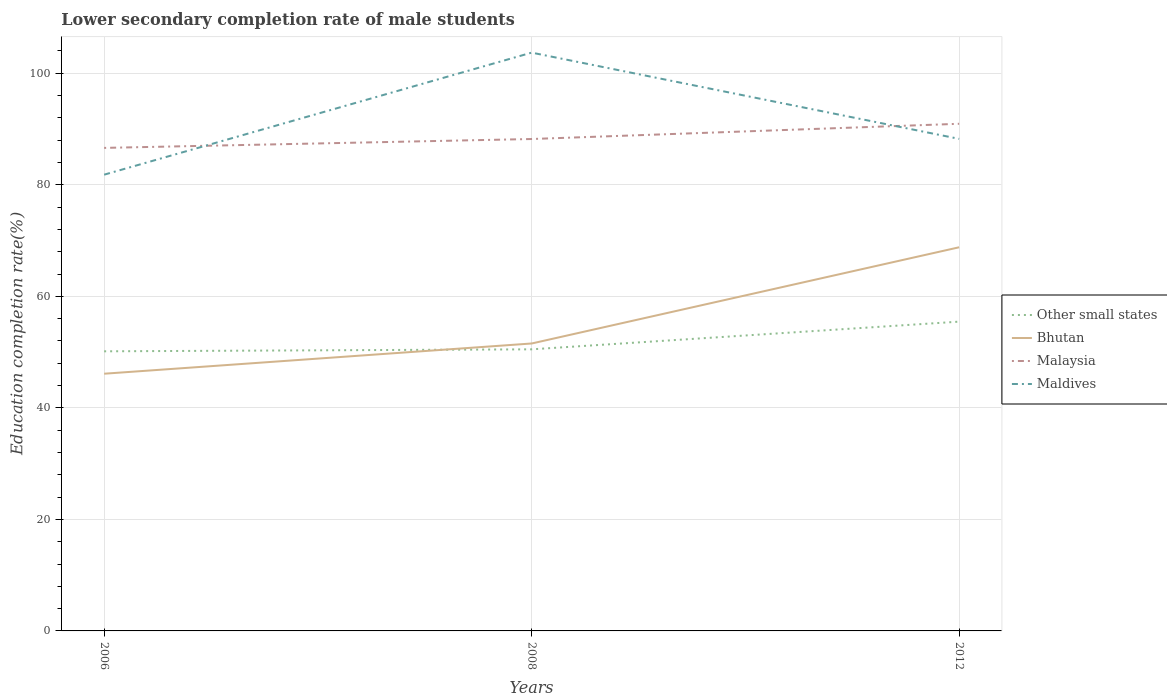How many different coloured lines are there?
Provide a short and direct response. 4. Is the number of lines equal to the number of legend labels?
Ensure brevity in your answer.  Yes. Across all years, what is the maximum lower secondary completion rate of male students in Bhutan?
Offer a very short reply. 46.12. In which year was the lower secondary completion rate of male students in Maldives maximum?
Make the answer very short. 2006. What is the total lower secondary completion rate of male students in Bhutan in the graph?
Provide a succinct answer. -22.68. What is the difference between the highest and the second highest lower secondary completion rate of male students in Bhutan?
Give a very brief answer. 22.68. Does the graph contain any zero values?
Make the answer very short. No. How many legend labels are there?
Provide a short and direct response. 4. How are the legend labels stacked?
Make the answer very short. Vertical. What is the title of the graph?
Provide a short and direct response. Lower secondary completion rate of male students. What is the label or title of the X-axis?
Provide a succinct answer. Years. What is the label or title of the Y-axis?
Ensure brevity in your answer.  Education completion rate(%). What is the Education completion rate(%) in Other small states in 2006?
Ensure brevity in your answer.  50.14. What is the Education completion rate(%) of Bhutan in 2006?
Offer a very short reply. 46.12. What is the Education completion rate(%) of Malaysia in 2006?
Offer a very short reply. 86.62. What is the Education completion rate(%) in Maldives in 2006?
Offer a terse response. 81.82. What is the Education completion rate(%) of Other small states in 2008?
Offer a terse response. 50.5. What is the Education completion rate(%) in Bhutan in 2008?
Keep it short and to the point. 51.54. What is the Education completion rate(%) in Malaysia in 2008?
Make the answer very short. 88.21. What is the Education completion rate(%) of Maldives in 2008?
Provide a succinct answer. 103.7. What is the Education completion rate(%) in Other small states in 2012?
Offer a terse response. 55.46. What is the Education completion rate(%) of Bhutan in 2012?
Provide a succinct answer. 68.8. What is the Education completion rate(%) of Malaysia in 2012?
Give a very brief answer. 90.94. What is the Education completion rate(%) in Maldives in 2012?
Make the answer very short. 88.24. Across all years, what is the maximum Education completion rate(%) of Other small states?
Provide a succinct answer. 55.46. Across all years, what is the maximum Education completion rate(%) in Bhutan?
Offer a terse response. 68.8. Across all years, what is the maximum Education completion rate(%) in Malaysia?
Offer a terse response. 90.94. Across all years, what is the maximum Education completion rate(%) of Maldives?
Keep it short and to the point. 103.7. Across all years, what is the minimum Education completion rate(%) of Other small states?
Offer a very short reply. 50.14. Across all years, what is the minimum Education completion rate(%) in Bhutan?
Your answer should be compact. 46.12. Across all years, what is the minimum Education completion rate(%) in Malaysia?
Ensure brevity in your answer.  86.62. Across all years, what is the minimum Education completion rate(%) in Maldives?
Offer a terse response. 81.82. What is the total Education completion rate(%) in Other small states in the graph?
Keep it short and to the point. 156.1. What is the total Education completion rate(%) of Bhutan in the graph?
Make the answer very short. 166.46. What is the total Education completion rate(%) in Malaysia in the graph?
Provide a succinct answer. 265.77. What is the total Education completion rate(%) in Maldives in the graph?
Offer a very short reply. 273.75. What is the difference between the Education completion rate(%) of Other small states in 2006 and that in 2008?
Provide a short and direct response. -0.36. What is the difference between the Education completion rate(%) in Bhutan in 2006 and that in 2008?
Give a very brief answer. -5.42. What is the difference between the Education completion rate(%) in Malaysia in 2006 and that in 2008?
Ensure brevity in your answer.  -1.59. What is the difference between the Education completion rate(%) in Maldives in 2006 and that in 2008?
Provide a short and direct response. -21.89. What is the difference between the Education completion rate(%) in Other small states in 2006 and that in 2012?
Give a very brief answer. -5.32. What is the difference between the Education completion rate(%) of Bhutan in 2006 and that in 2012?
Your response must be concise. -22.68. What is the difference between the Education completion rate(%) in Malaysia in 2006 and that in 2012?
Keep it short and to the point. -4.32. What is the difference between the Education completion rate(%) of Maldives in 2006 and that in 2012?
Make the answer very short. -6.42. What is the difference between the Education completion rate(%) in Other small states in 2008 and that in 2012?
Your answer should be compact. -4.97. What is the difference between the Education completion rate(%) in Bhutan in 2008 and that in 2012?
Give a very brief answer. -17.25. What is the difference between the Education completion rate(%) in Malaysia in 2008 and that in 2012?
Your answer should be compact. -2.73. What is the difference between the Education completion rate(%) in Maldives in 2008 and that in 2012?
Provide a succinct answer. 15.46. What is the difference between the Education completion rate(%) of Other small states in 2006 and the Education completion rate(%) of Bhutan in 2008?
Your answer should be compact. -1.4. What is the difference between the Education completion rate(%) of Other small states in 2006 and the Education completion rate(%) of Malaysia in 2008?
Provide a succinct answer. -38.07. What is the difference between the Education completion rate(%) of Other small states in 2006 and the Education completion rate(%) of Maldives in 2008?
Your answer should be compact. -53.56. What is the difference between the Education completion rate(%) of Bhutan in 2006 and the Education completion rate(%) of Malaysia in 2008?
Your answer should be very brief. -42.09. What is the difference between the Education completion rate(%) of Bhutan in 2006 and the Education completion rate(%) of Maldives in 2008?
Your answer should be very brief. -57.58. What is the difference between the Education completion rate(%) of Malaysia in 2006 and the Education completion rate(%) of Maldives in 2008?
Provide a short and direct response. -17.08. What is the difference between the Education completion rate(%) in Other small states in 2006 and the Education completion rate(%) in Bhutan in 2012?
Offer a very short reply. -18.66. What is the difference between the Education completion rate(%) of Other small states in 2006 and the Education completion rate(%) of Malaysia in 2012?
Provide a short and direct response. -40.8. What is the difference between the Education completion rate(%) of Other small states in 2006 and the Education completion rate(%) of Maldives in 2012?
Offer a terse response. -38.1. What is the difference between the Education completion rate(%) in Bhutan in 2006 and the Education completion rate(%) in Malaysia in 2012?
Your answer should be very brief. -44.82. What is the difference between the Education completion rate(%) in Bhutan in 2006 and the Education completion rate(%) in Maldives in 2012?
Ensure brevity in your answer.  -42.11. What is the difference between the Education completion rate(%) in Malaysia in 2006 and the Education completion rate(%) in Maldives in 2012?
Your response must be concise. -1.62. What is the difference between the Education completion rate(%) in Other small states in 2008 and the Education completion rate(%) in Bhutan in 2012?
Give a very brief answer. -18.3. What is the difference between the Education completion rate(%) of Other small states in 2008 and the Education completion rate(%) of Malaysia in 2012?
Provide a short and direct response. -40.45. What is the difference between the Education completion rate(%) in Other small states in 2008 and the Education completion rate(%) in Maldives in 2012?
Offer a terse response. -37.74. What is the difference between the Education completion rate(%) of Bhutan in 2008 and the Education completion rate(%) of Malaysia in 2012?
Your answer should be very brief. -39.4. What is the difference between the Education completion rate(%) of Bhutan in 2008 and the Education completion rate(%) of Maldives in 2012?
Offer a terse response. -36.69. What is the difference between the Education completion rate(%) of Malaysia in 2008 and the Education completion rate(%) of Maldives in 2012?
Provide a short and direct response. -0.03. What is the average Education completion rate(%) in Other small states per year?
Make the answer very short. 52.03. What is the average Education completion rate(%) in Bhutan per year?
Provide a succinct answer. 55.49. What is the average Education completion rate(%) in Malaysia per year?
Give a very brief answer. 88.59. What is the average Education completion rate(%) of Maldives per year?
Provide a short and direct response. 91.25. In the year 2006, what is the difference between the Education completion rate(%) of Other small states and Education completion rate(%) of Bhutan?
Your response must be concise. 4.02. In the year 2006, what is the difference between the Education completion rate(%) in Other small states and Education completion rate(%) in Malaysia?
Provide a short and direct response. -36.48. In the year 2006, what is the difference between the Education completion rate(%) in Other small states and Education completion rate(%) in Maldives?
Your answer should be very brief. -31.68. In the year 2006, what is the difference between the Education completion rate(%) of Bhutan and Education completion rate(%) of Malaysia?
Your response must be concise. -40.5. In the year 2006, what is the difference between the Education completion rate(%) in Bhutan and Education completion rate(%) in Maldives?
Give a very brief answer. -35.69. In the year 2006, what is the difference between the Education completion rate(%) of Malaysia and Education completion rate(%) of Maldives?
Provide a short and direct response. 4.8. In the year 2008, what is the difference between the Education completion rate(%) of Other small states and Education completion rate(%) of Bhutan?
Your response must be concise. -1.05. In the year 2008, what is the difference between the Education completion rate(%) of Other small states and Education completion rate(%) of Malaysia?
Your response must be concise. -37.71. In the year 2008, what is the difference between the Education completion rate(%) in Other small states and Education completion rate(%) in Maldives?
Your answer should be compact. -53.2. In the year 2008, what is the difference between the Education completion rate(%) in Bhutan and Education completion rate(%) in Malaysia?
Keep it short and to the point. -36.67. In the year 2008, what is the difference between the Education completion rate(%) in Bhutan and Education completion rate(%) in Maldives?
Give a very brief answer. -52.16. In the year 2008, what is the difference between the Education completion rate(%) in Malaysia and Education completion rate(%) in Maldives?
Your answer should be compact. -15.49. In the year 2012, what is the difference between the Education completion rate(%) in Other small states and Education completion rate(%) in Bhutan?
Your answer should be compact. -13.34. In the year 2012, what is the difference between the Education completion rate(%) of Other small states and Education completion rate(%) of Malaysia?
Your answer should be very brief. -35.48. In the year 2012, what is the difference between the Education completion rate(%) of Other small states and Education completion rate(%) of Maldives?
Ensure brevity in your answer.  -32.77. In the year 2012, what is the difference between the Education completion rate(%) in Bhutan and Education completion rate(%) in Malaysia?
Ensure brevity in your answer.  -22.14. In the year 2012, what is the difference between the Education completion rate(%) of Bhutan and Education completion rate(%) of Maldives?
Provide a short and direct response. -19.44. In the year 2012, what is the difference between the Education completion rate(%) of Malaysia and Education completion rate(%) of Maldives?
Your answer should be compact. 2.71. What is the ratio of the Education completion rate(%) in Other small states in 2006 to that in 2008?
Your response must be concise. 0.99. What is the ratio of the Education completion rate(%) of Bhutan in 2006 to that in 2008?
Your answer should be compact. 0.89. What is the ratio of the Education completion rate(%) of Malaysia in 2006 to that in 2008?
Make the answer very short. 0.98. What is the ratio of the Education completion rate(%) of Maldives in 2006 to that in 2008?
Offer a terse response. 0.79. What is the ratio of the Education completion rate(%) in Other small states in 2006 to that in 2012?
Provide a succinct answer. 0.9. What is the ratio of the Education completion rate(%) of Bhutan in 2006 to that in 2012?
Keep it short and to the point. 0.67. What is the ratio of the Education completion rate(%) in Malaysia in 2006 to that in 2012?
Make the answer very short. 0.95. What is the ratio of the Education completion rate(%) in Maldives in 2006 to that in 2012?
Your answer should be very brief. 0.93. What is the ratio of the Education completion rate(%) in Other small states in 2008 to that in 2012?
Offer a terse response. 0.91. What is the ratio of the Education completion rate(%) of Bhutan in 2008 to that in 2012?
Offer a very short reply. 0.75. What is the ratio of the Education completion rate(%) in Maldives in 2008 to that in 2012?
Offer a very short reply. 1.18. What is the difference between the highest and the second highest Education completion rate(%) of Other small states?
Provide a short and direct response. 4.97. What is the difference between the highest and the second highest Education completion rate(%) of Bhutan?
Ensure brevity in your answer.  17.25. What is the difference between the highest and the second highest Education completion rate(%) of Malaysia?
Ensure brevity in your answer.  2.73. What is the difference between the highest and the second highest Education completion rate(%) of Maldives?
Your answer should be compact. 15.46. What is the difference between the highest and the lowest Education completion rate(%) in Other small states?
Offer a terse response. 5.32. What is the difference between the highest and the lowest Education completion rate(%) of Bhutan?
Give a very brief answer. 22.68. What is the difference between the highest and the lowest Education completion rate(%) in Malaysia?
Offer a terse response. 4.32. What is the difference between the highest and the lowest Education completion rate(%) in Maldives?
Keep it short and to the point. 21.89. 